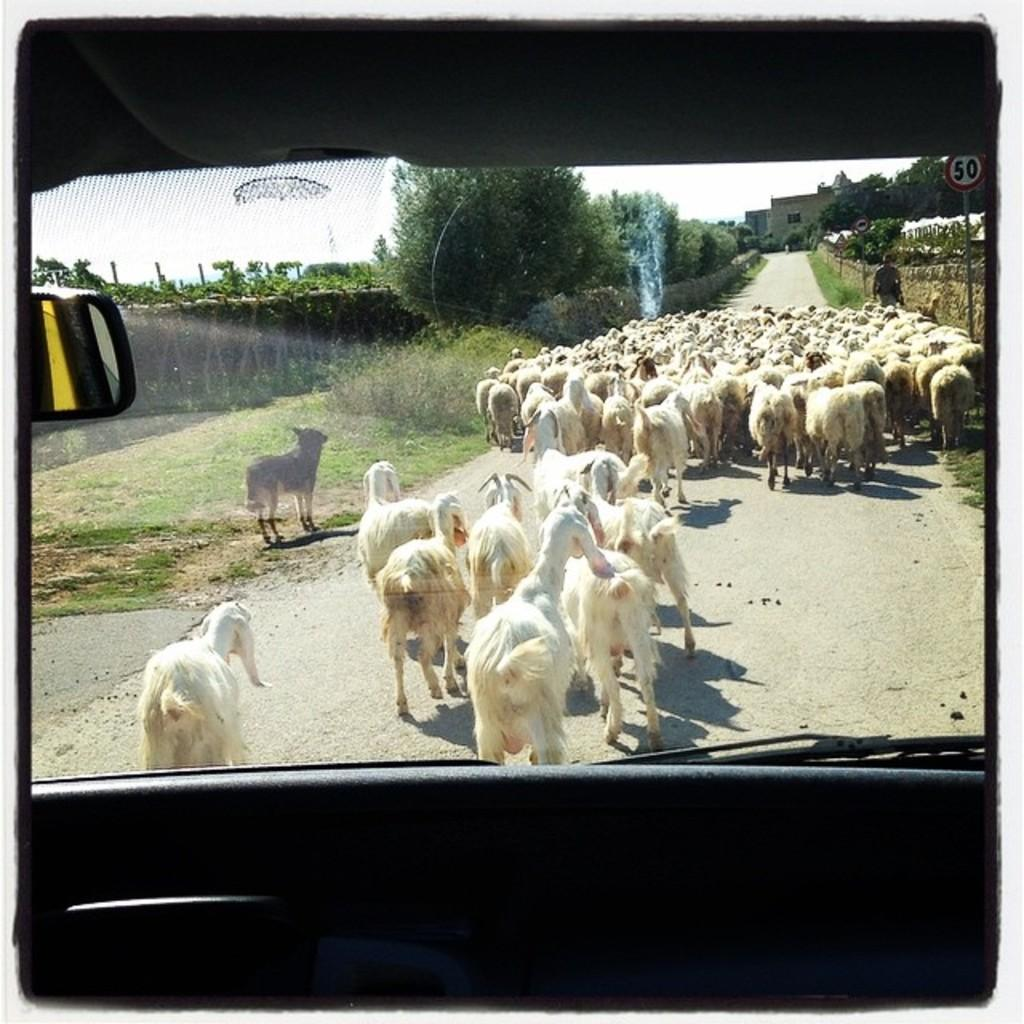What animals are present in the image? There is a herd of goats in the image. Where are the goats located in the image? The goats are standing on the road. What type of vegetation can be seen in the image? There are trees and grass visible in the image. What can be seen in the background of the image? There are buildings visible in the background. How many toy giants are holding the goats in the image? There are no toy giants present in the image, and the goats are not being held by any figures. 